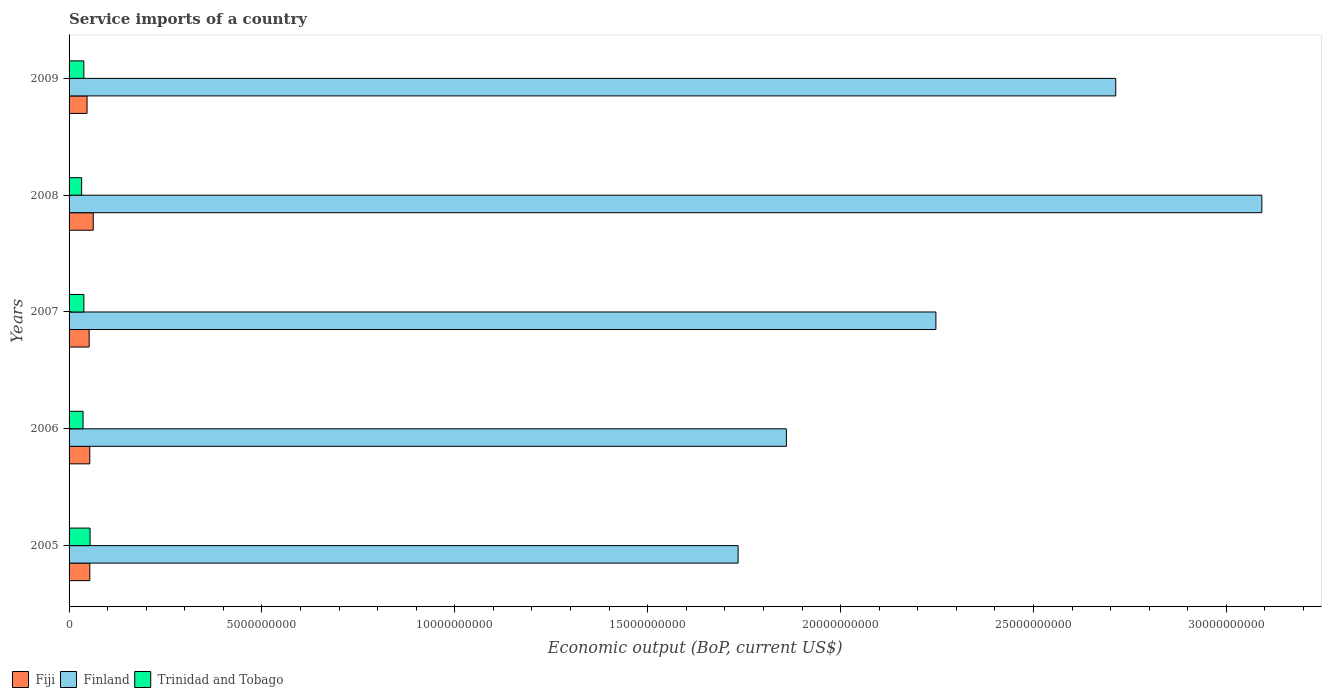How many groups of bars are there?
Your answer should be very brief. 5. Are the number of bars on each tick of the Y-axis equal?
Make the answer very short. Yes. How many bars are there on the 1st tick from the top?
Make the answer very short. 3. In how many cases, is the number of bars for a given year not equal to the number of legend labels?
Ensure brevity in your answer.  0. What is the service imports in Trinidad and Tobago in 2008?
Offer a very short reply. 3.26e+08. Across all years, what is the maximum service imports in Finland?
Your answer should be very brief. 3.09e+1. Across all years, what is the minimum service imports in Fiji?
Your answer should be compact. 4.66e+08. What is the total service imports in Finland in the graph?
Provide a succinct answer. 1.16e+11. What is the difference between the service imports in Trinidad and Tobago in 2005 and that in 2009?
Your response must be concise. 1.61e+08. What is the difference between the service imports in Finland in 2009 and the service imports in Trinidad and Tobago in 2007?
Offer a terse response. 2.67e+1. What is the average service imports in Fiji per year?
Ensure brevity in your answer.  5.37e+08. In the year 2006, what is the difference between the service imports in Finland and service imports in Fiji?
Provide a short and direct response. 1.81e+1. What is the ratio of the service imports in Fiji in 2006 to that in 2009?
Offer a very short reply. 1.15. Is the service imports in Finland in 2007 less than that in 2008?
Keep it short and to the point. Yes. Is the difference between the service imports in Finland in 2007 and 2008 greater than the difference between the service imports in Fiji in 2007 and 2008?
Your response must be concise. No. What is the difference between the highest and the second highest service imports in Fiji?
Offer a very short reply. 8.93e+07. What is the difference between the highest and the lowest service imports in Trinidad and Tobago?
Ensure brevity in your answer.  2.19e+08. Is the sum of the service imports in Finland in 2006 and 2009 greater than the maximum service imports in Fiji across all years?
Your response must be concise. Yes. What does the 1st bar from the top in 2007 represents?
Your response must be concise. Trinidad and Tobago. What does the 3rd bar from the bottom in 2005 represents?
Your answer should be very brief. Trinidad and Tobago. Is it the case that in every year, the sum of the service imports in Trinidad and Tobago and service imports in Finland is greater than the service imports in Fiji?
Make the answer very short. Yes. How many bars are there?
Ensure brevity in your answer.  15. What is the difference between two consecutive major ticks on the X-axis?
Offer a terse response. 5.00e+09. Are the values on the major ticks of X-axis written in scientific E-notation?
Your answer should be compact. No. What is the title of the graph?
Provide a succinct answer. Service imports of a country. What is the label or title of the X-axis?
Your answer should be compact. Economic output (BoP, current US$). What is the Economic output (BoP, current US$) of Fiji in 2005?
Keep it short and to the point. 5.37e+08. What is the Economic output (BoP, current US$) of Finland in 2005?
Give a very brief answer. 1.73e+1. What is the Economic output (BoP, current US$) in Trinidad and Tobago in 2005?
Provide a succinct answer. 5.45e+08. What is the Economic output (BoP, current US$) in Fiji in 2006?
Your answer should be compact. 5.37e+08. What is the Economic output (BoP, current US$) in Finland in 2006?
Provide a short and direct response. 1.86e+1. What is the Economic output (BoP, current US$) of Trinidad and Tobago in 2006?
Offer a very short reply. 3.63e+08. What is the Economic output (BoP, current US$) in Fiji in 2007?
Provide a short and direct response. 5.20e+08. What is the Economic output (BoP, current US$) of Finland in 2007?
Provide a short and direct response. 2.25e+1. What is the Economic output (BoP, current US$) of Trinidad and Tobago in 2007?
Give a very brief answer. 3.84e+08. What is the Economic output (BoP, current US$) of Fiji in 2008?
Make the answer very short. 6.27e+08. What is the Economic output (BoP, current US$) in Finland in 2008?
Your answer should be very brief. 3.09e+1. What is the Economic output (BoP, current US$) of Trinidad and Tobago in 2008?
Provide a succinct answer. 3.26e+08. What is the Economic output (BoP, current US$) in Fiji in 2009?
Make the answer very short. 4.66e+08. What is the Economic output (BoP, current US$) in Finland in 2009?
Your answer should be compact. 2.71e+1. What is the Economic output (BoP, current US$) in Trinidad and Tobago in 2009?
Ensure brevity in your answer.  3.83e+08. Across all years, what is the maximum Economic output (BoP, current US$) in Fiji?
Offer a very short reply. 6.27e+08. Across all years, what is the maximum Economic output (BoP, current US$) in Finland?
Give a very brief answer. 3.09e+1. Across all years, what is the maximum Economic output (BoP, current US$) of Trinidad and Tobago?
Your answer should be compact. 5.45e+08. Across all years, what is the minimum Economic output (BoP, current US$) of Fiji?
Provide a succinct answer. 4.66e+08. Across all years, what is the minimum Economic output (BoP, current US$) in Finland?
Keep it short and to the point. 1.73e+1. Across all years, what is the minimum Economic output (BoP, current US$) in Trinidad and Tobago?
Make the answer very short. 3.26e+08. What is the total Economic output (BoP, current US$) of Fiji in the graph?
Make the answer very short. 2.69e+09. What is the total Economic output (BoP, current US$) of Finland in the graph?
Your answer should be very brief. 1.16e+11. What is the total Economic output (BoP, current US$) in Trinidad and Tobago in the graph?
Ensure brevity in your answer.  2.00e+09. What is the difference between the Economic output (BoP, current US$) of Fiji in 2005 and that in 2006?
Your answer should be very brief. 4.78e+05. What is the difference between the Economic output (BoP, current US$) of Finland in 2005 and that in 2006?
Provide a succinct answer. -1.25e+09. What is the difference between the Economic output (BoP, current US$) in Trinidad and Tobago in 2005 and that in 2006?
Your response must be concise. 1.82e+08. What is the difference between the Economic output (BoP, current US$) in Fiji in 2005 and that in 2007?
Ensure brevity in your answer.  1.69e+07. What is the difference between the Economic output (BoP, current US$) in Finland in 2005 and that in 2007?
Your response must be concise. -5.13e+09. What is the difference between the Economic output (BoP, current US$) in Trinidad and Tobago in 2005 and that in 2007?
Your answer should be very brief. 1.60e+08. What is the difference between the Economic output (BoP, current US$) in Fiji in 2005 and that in 2008?
Your response must be concise. -8.93e+07. What is the difference between the Economic output (BoP, current US$) in Finland in 2005 and that in 2008?
Provide a succinct answer. -1.36e+1. What is the difference between the Economic output (BoP, current US$) of Trinidad and Tobago in 2005 and that in 2008?
Keep it short and to the point. 2.19e+08. What is the difference between the Economic output (BoP, current US$) in Fiji in 2005 and that in 2009?
Your response must be concise. 7.10e+07. What is the difference between the Economic output (BoP, current US$) of Finland in 2005 and that in 2009?
Give a very brief answer. -9.79e+09. What is the difference between the Economic output (BoP, current US$) in Trinidad and Tobago in 2005 and that in 2009?
Make the answer very short. 1.61e+08. What is the difference between the Economic output (BoP, current US$) of Fiji in 2006 and that in 2007?
Offer a terse response. 1.64e+07. What is the difference between the Economic output (BoP, current US$) in Finland in 2006 and that in 2007?
Your answer should be compact. -3.88e+09. What is the difference between the Economic output (BoP, current US$) of Trinidad and Tobago in 2006 and that in 2007?
Keep it short and to the point. -2.13e+07. What is the difference between the Economic output (BoP, current US$) in Fiji in 2006 and that in 2008?
Keep it short and to the point. -8.98e+07. What is the difference between the Economic output (BoP, current US$) of Finland in 2006 and that in 2008?
Your answer should be compact. -1.23e+1. What is the difference between the Economic output (BoP, current US$) in Trinidad and Tobago in 2006 and that in 2008?
Your answer should be very brief. 3.68e+07. What is the difference between the Economic output (BoP, current US$) of Fiji in 2006 and that in 2009?
Your answer should be compact. 7.06e+07. What is the difference between the Economic output (BoP, current US$) of Finland in 2006 and that in 2009?
Ensure brevity in your answer.  -8.54e+09. What is the difference between the Economic output (BoP, current US$) in Trinidad and Tobago in 2006 and that in 2009?
Your answer should be very brief. -2.05e+07. What is the difference between the Economic output (BoP, current US$) in Fiji in 2007 and that in 2008?
Provide a succinct answer. -1.06e+08. What is the difference between the Economic output (BoP, current US$) in Finland in 2007 and that in 2008?
Offer a terse response. -8.45e+09. What is the difference between the Economic output (BoP, current US$) of Trinidad and Tobago in 2007 and that in 2008?
Make the answer very short. 5.81e+07. What is the difference between the Economic output (BoP, current US$) in Fiji in 2007 and that in 2009?
Keep it short and to the point. 5.41e+07. What is the difference between the Economic output (BoP, current US$) of Finland in 2007 and that in 2009?
Your response must be concise. -4.66e+09. What is the difference between the Economic output (BoP, current US$) in Trinidad and Tobago in 2007 and that in 2009?
Your response must be concise. 8.00e+05. What is the difference between the Economic output (BoP, current US$) of Fiji in 2008 and that in 2009?
Provide a succinct answer. 1.60e+08. What is the difference between the Economic output (BoP, current US$) in Finland in 2008 and that in 2009?
Keep it short and to the point. 3.79e+09. What is the difference between the Economic output (BoP, current US$) in Trinidad and Tobago in 2008 and that in 2009?
Provide a short and direct response. -5.73e+07. What is the difference between the Economic output (BoP, current US$) of Fiji in 2005 and the Economic output (BoP, current US$) of Finland in 2006?
Offer a terse response. -1.81e+1. What is the difference between the Economic output (BoP, current US$) of Fiji in 2005 and the Economic output (BoP, current US$) of Trinidad and Tobago in 2006?
Offer a very short reply. 1.74e+08. What is the difference between the Economic output (BoP, current US$) in Finland in 2005 and the Economic output (BoP, current US$) in Trinidad and Tobago in 2006?
Provide a short and direct response. 1.70e+1. What is the difference between the Economic output (BoP, current US$) of Fiji in 2005 and the Economic output (BoP, current US$) of Finland in 2007?
Keep it short and to the point. -2.19e+1. What is the difference between the Economic output (BoP, current US$) in Fiji in 2005 and the Economic output (BoP, current US$) in Trinidad and Tobago in 2007?
Make the answer very short. 1.53e+08. What is the difference between the Economic output (BoP, current US$) of Finland in 2005 and the Economic output (BoP, current US$) of Trinidad and Tobago in 2007?
Provide a short and direct response. 1.70e+1. What is the difference between the Economic output (BoP, current US$) of Fiji in 2005 and the Economic output (BoP, current US$) of Finland in 2008?
Provide a succinct answer. -3.04e+1. What is the difference between the Economic output (BoP, current US$) in Fiji in 2005 and the Economic output (BoP, current US$) in Trinidad and Tobago in 2008?
Provide a succinct answer. 2.11e+08. What is the difference between the Economic output (BoP, current US$) in Finland in 2005 and the Economic output (BoP, current US$) in Trinidad and Tobago in 2008?
Give a very brief answer. 1.70e+1. What is the difference between the Economic output (BoP, current US$) in Fiji in 2005 and the Economic output (BoP, current US$) in Finland in 2009?
Provide a short and direct response. -2.66e+1. What is the difference between the Economic output (BoP, current US$) in Fiji in 2005 and the Economic output (BoP, current US$) in Trinidad and Tobago in 2009?
Keep it short and to the point. 1.54e+08. What is the difference between the Economic output (BoP, current US$) of Finland in 2005 and the Economic output (BoP, current US$) of Trinidad and Tobago in 2009?
Offer a very short reply. 1.70e+1. What is the difference between the Economic output (BoP, current US$) in Fiji in 2006 and the Economic output (BoP, current US$) in Finland in 2007?
Offer a very short reply. -2.19e+1. What is the difference between the Economic output (BoP, current US$) of Fiji in 2006 and the Economic output (BoP, current US$) of Trinidad and Tobago in 2007?
Your response must be concise. 1.53e+08. What is the difference between the Economic output (BoP, current US$) in Finland in 2006 and the Economic output (BoP, current US$) in Trinidad and Tobago in 2007?
Ensure brevity in your answer.  1.82e+1. What is the difference between the Economic output (BoP, current US$) of Fiji in 2006 and the Economic output (BoP, current US$) of Finland in 2008?
Keep it short and to the point. -3.04e+1. What is the difference between the Economic output (BoP, current US$) in Fiji in 2006 and the Economic output (BoP, current US$) in Trinidad and Tobago in 2008?
Offer a terse response. 2.11e+08. What is the difference between the Economic output (BoP, current US$) of Finland in 2006 and the Economic output (BoP, current US$) of Trinidad and Tobago in 2008?
Make the answer very short. 1.83e+1. What is the difference between the Economic output (BoP, current US$) in Fiji in 2006 and the Economic output (BoP, current US$) in Finland in 2009?
Your response must be concise. -2.66e+1. What is the difference between the Economic output (BoP, current US$) in Fiji in 2006 and the Economic output (BoP, current US$) in Trinidad and Tobago in 2009?
Keep it short and to the point. 1.53e+08. What is the difference between the Economic output (BoP, current US$) of Finland in 2006 and the Economic output (BoP, current US$) of Trinidad and Tobago in 2009?
Provide a succinct answer. 1.82e+1. What is the difference between the Economic output (BoP, current US$) in Fiji in 2007 and the Economic output (BoP, current US$) in Finland in 2008?
Ensure brevity in your answer.  -3.04e+1. What is the difference between the Economic output (BoP, current US$) in Fiji in 2007 and the Economic output (BoP, current US$) in Trinidad and Tobago in 2008?
Give a very brief answer. 1.94e+08. What is the difference between the Economic output (BoP, current US$) in Finland in 2007 and the Economic output (BoP, current US$) in Trinidad and Tobago in 2008?
Your response must be concise. 2.21e+1. What is the difference between the Economic output (BoP, current US$) in Fiji in 2007 and the Economic output (BoP, current US$) in Finland in 2009?
Your response must be concise. -2.66e+1. What is the difference between the Economic output (BoP, current US$) in Fiji in 2007 and the Economic output (BoP, current US$) in Trinidad and Tobago in 2009?
Provide a succinct answer. 1.37e+08. What is the difference between the Economic output (BoP, current US$) in Finland in 2007 and the Economic output (BoP, current US$) in Trinidad and Tobago in 2009?
Your answer should be very brief. 2.21e+1. What is the difference between the Economic output (BoP, current US$) in Fiji in 2008 and the Economic output (BoP, current US$) in Finland in 2009?
Your answer should be very brief. -2.65e+1. What is the difference between the Economic output (BoP, current US$) in Fiji in 2008 and the Economic output (BoP, current US$) in Trinidad and Tobago in 2009?
Your answer should be compact. 2.43e+08. What is the difference between the Economic output (BoP, current US$) of Finland in 2008 and the Economic output (BoP, current US$) of Trinidad and Tobago in 2009?
Keep it short and to the point. 3.05e+1. What is the average Economic output (BoP, current US$) in Fiji per year?
Provide a short and direct response. 5.37e+08. What is the average Economic output (BoP, current US$) of Finland per year?
Your response must be concise. 2.33e+1. What is the average Economic output (BoP, current US$) of Trinidad and Tobago per year?
Make the answer very short. 4.00e+08. In the year 2005, what is the difference between the Economic output (BoP, current US$) of Fiji and Economic output (BoP, current US$) of Finland?
Make the answer very short. -1.68e+1. In the year 2005, what is the difference between the Economic output (BoP, current US$) of Fiji and Economic output (BoP, current US$) of Trinidad and Tobago?
Ensure brevity in your answer.  -7.41e+06. In the year 2005, what is the difference between the Economic output (BoP, current US$) in Finland and Economic output (BoP, current US$) in Trinidad and Tobago?
Make the answer very short. 1.68e+1. In the year 2006, what is the difference between the Economic output (BoP, current US$) in Fiji and Economic output (BoP, current US$) in Finland?
Keep it short and to the point. -1.81e+1. In the year 2006, what is the difference between the Economic output (BoP, current US$) of Fiji and Economic output (BoP, current US$) of Trinidad and Tobago?
Ensure brevity in your answer.  1.74e+08. In the year 2006, what is the difference between the Economic output (BoP, current US$) in Finland and Economic output (BoP, current US$) in Trinidad and Tobago?
Make the answer very short. 1.82e+1. In the year 2007, what is the difference between the Economic output (BoP, current US$) of Fiji and Economic output (BoP, current US$) of Finland?
Your answer should be very brief. -2.20e+1. In the year 2007, what is the difference between the Economic output (BoP, current US$) of Fiji and Economic output (BoP, current US$) of Trinidad and Tobago?
Provide a succinct answer. 1.36e+08. In the year 2007, what is the difference between the Economic output (BoP, current US$) of Finland and Economic output (BoP, current US$) of Trinidad and Tobago?
Make the answer very short. 2.21e+1. In the year 2008, what is the difference between the Economic output (BoP, current US$) in Fiji and Economic output (BoP, current US$) in Finland?
Provide a succinct answer. -3.03e+1. In the year 2008, what is the difference between the Economic output (BoP, current US$) of Fiji and Economic output (BoP, current US$) of Trinidad and Tobago?
Offer a very short reply. 3.01e+08. In the year 2008, what is the difference between the Economic output (BoP, current US$) in Finland and Economic output (BoP, current US$) in Trinidad and Tobago?
Keep it short and to the point. 3.06e+1. In the year 2009, what is the difference between the Economic output (BoP, current US$) of Fiji and Economic output (BoP, current US$) of Finland?
Make the answer very short. -2.67e+1. In the year 2009, what is the difference between the Economic output (BoP, current US$) in Fiji and Economic output (BoP, current US$) in Trinidad and Tobago?
Offer a terse response. 8.29e+07. In the year 2009, what is the difference between the Economic output (BoP, current US$) of Finland and Economic output (BoP, current US$) of Trinidad and Tobago?
Offer a very short reply. 2.67e+1. What is the ratio of the Economic output (BoP, current US$) of Fiji in 2005 to that in 2006?
Offer a terse response. 1. What is the ratio of the Economic output (BoP, current US$) of Finland in 2005 to that in 2006?
Provide a succinct answer. 0.93. What is the ratio of the Economic output (BoP, current US$) of Trinidad and Tobago in 2005 to that in 2006?
Provide a succinct answer. 1.5. What is the ratio of the Economic output (BoP, current US$) in Fiji in 2005 to that in 2007?
Make the answer very short. 1.03. What is the ratio of the Economic output (BoP, current US$) of Finland in 2005 to that in 2007?
Offer a terse response. 0.77. What is the ratio of the Economic output (BoP, current US$) in Trinidad and Tobago in 2005 to that in 2007?
Offer a very short reply. 1.42. What is the ratio of the Economic output (BoP, current US$) of Fiji in 2005 to that in 2008?
Offer a terse response. 0.86. What is the ratio of the Economic output (BoP, current US$) in Finland in 2005 to that in 2008?
Your response must be concise. 0.56. What is the ratio of the Economic output (BoP, current US$) of Trinidad and Tobago in 2005 to that in 2008?
Give a very brief answer. 1.67. What is the ratio of the Economic output (BoP, current US$) in Fiji in 2005 to that in 2009?
Make the answer very short. 1.15. What is the ratio of the Economic output (BoP, current US$) in Finland in 2005 to that in 2009?
Make the answer very short. 0.64. What is the ratio of the Economic output (BoP, current US$) of Trinidad and Tobago in 2005 to that in 2009?
Your response must be concise. 1.42. What is the ratio of the Economic output (BoP, current US$) in Fiji in 2006 to that in 2007?
Provide a short and direct response. 1.03. What is the ratio of the Economic output (BoP, current US$) of Finland in 2006 to that in 2007?
Make the answer very short. 0.83. What is the ratio of the Economic output (BoP, current US$) of Trinidad and Tobago in 2006 to that in 2007?
Your answer should be very brief. 0.94. What is the ratio of the Economic output (BoP, current US$) in Fiji in 2006 to that in 2008?
Your answer should be compact. 0.86. What is the ratio of the Economic output (BoP, current US$) of Finland in 2006 to that in 2008?
Provide a short and direct response. 0.6. What is the ratio of the Economic output (BoP, current US$) in Trinidad and Tobago in 2006 to that in 2008?
Ensure brevity in your answer.  1.11. What is the ratio of the Economic output (BoP, current US$) of Fiji in 2006 to that in 2009?
Your response must be concise. 1.15. What is the ratio of the Economic output (BoP, current US$) in Finland in 2006 to that in 2009?
Provide a succinct answer. 0.69. What is the ratio of the Economic output (BoP, current US$) in Trinidad and Tobago in 2006 to that in 2009?
Keep it short and to the point. 0.95. What is the ratio of the Economic output (BoP, current US$) of Fiji in 2007 to that in 2008?
Your response must be concise. 0.83. What is the ratio of the Economic output (BoP, current US$) in Finland in 2007 to that in 2008?
Offer a terse response. 0.73. What is the ratio of the Economic output (BoP, current US$) of Trinidad and Tobago in 2007 to that in 2008?
Ensure brevity in your answer.  1.18. What is the ratio of the Economic output (BoP, current US$) of Fiji in 2007 to that in 2009?
Offer a very short reply. 1.12. What is the ratio of the Economic output (BoP, current US$) of Finland in 2007 to that in 2009?
Your answer should be very brief. 0.83. What is the ratio of the Economic output (BoP, current US$) in Trinidad and Tobago in 2007 to that in 2009?
Offer a terse response. 1. What is the ratio of the Economic output (BoP, current US$) in Fiji in 2008 to that in 2009?
Your answer should be very brief. 1.34. What is the ratio of the Economic output (BoP, current US$) of Finland in 2008 to that in 2009?
Provide a short and direct response. 1.14. What is the ratio of the Economic output (BoP, current US$) in Trinidad and Tobago in 2008 to that in 2009?
Offer a terse response. 0.85. What is the difference between the highest and the second highest Economic output (BoP, current US$) of Fiji?
Give a very brief answer. 8.93e+07. What is the difference between the highest and the second highest Economic output (BoP, current US$) of Finland?
Provide a short and direct response. 3.79e+09. What is the difference between the highest and the second highest Economic output (BoP, current US$) in Trinidad and Tobago?
Ensure brevity in your answer.  1.60e+08. What is the difference between the highest and the lowest Economic output (BoP, current US$) of Fiji?
Make the answer very short. 1.60e+08. What is the difference between the highest and the lowest Economic output (BoP, current US$) of Finland?
Offer a terse response. 1.36e+1. What is the difference between the highest and the lowest Economic output (BoP, current US$) in Trinidad and Tobago?
Your answer should be compact. 2.19e+08. 